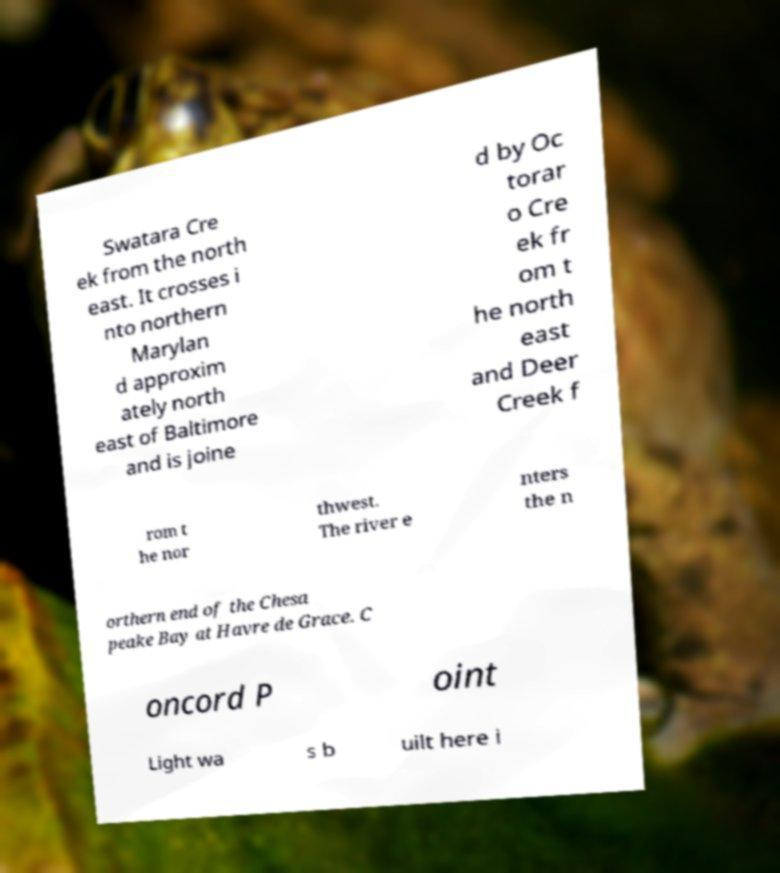There's text embedded in this image that I need extracted. Can you transcribe it verbatim? Swatara Cre ek from the north east. It crosses i nto northern Marylan d approxim ately north east of Baltimore and is joine d by Oc torar o Cre ek fr om t he north east and Deer Creek f rom t he nor thwest. The river e nters the n orthern end of the Chesa peake Bay at Havre de Grace. C oncord P oint Light wa s b uilt here i 